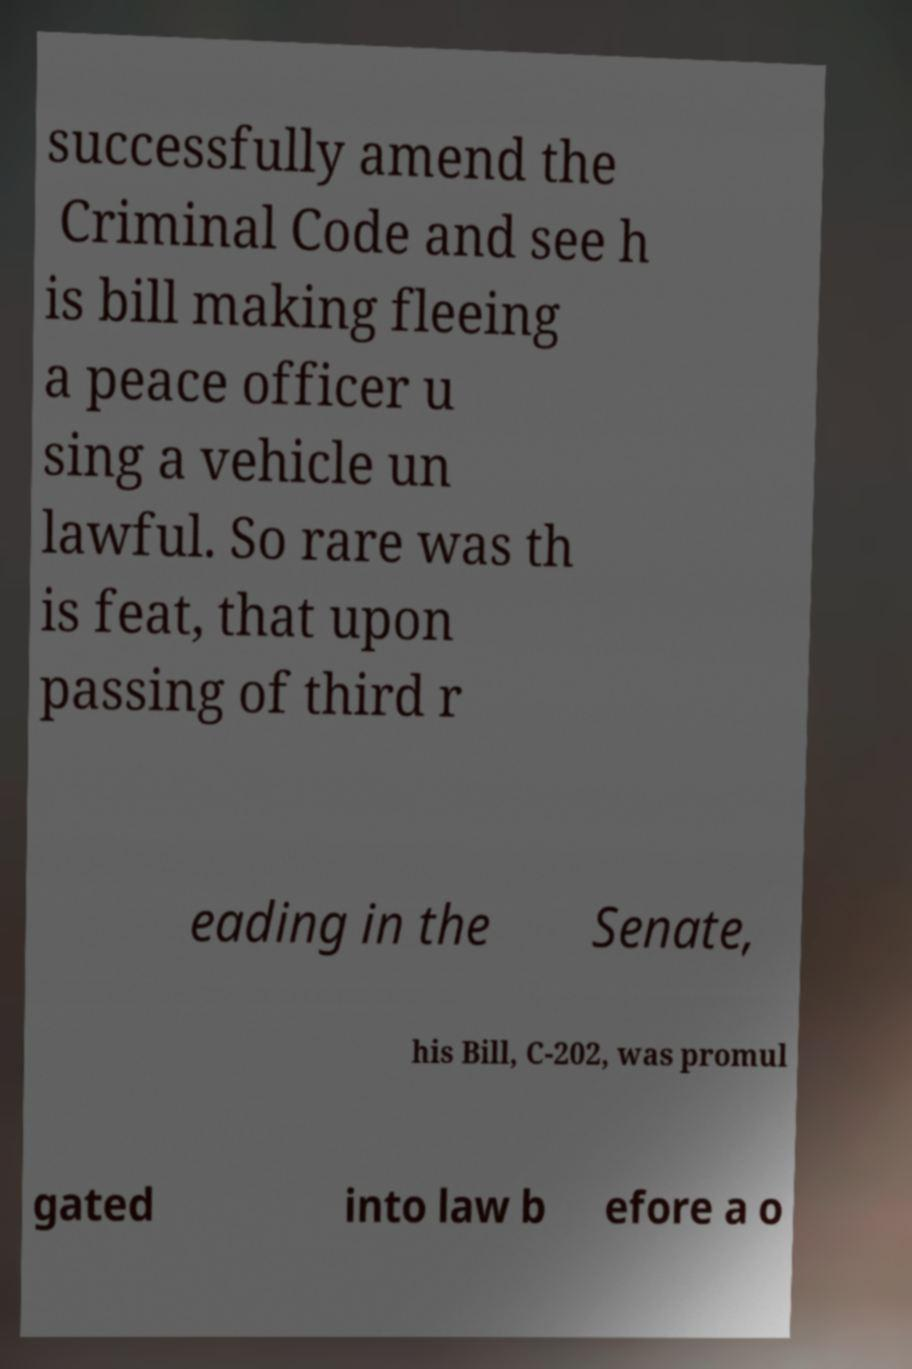For documentation purposes, I need the text within this image transcribed. Could you provide that? successfully amend the Criminal Code and see h is bill making fleeing a peace officer u sing a vehicle un lawful. So rare was th is feat, that upon passing of third r eading in the Senate, his Bill, C-202, was promul gated into law b efore a o 